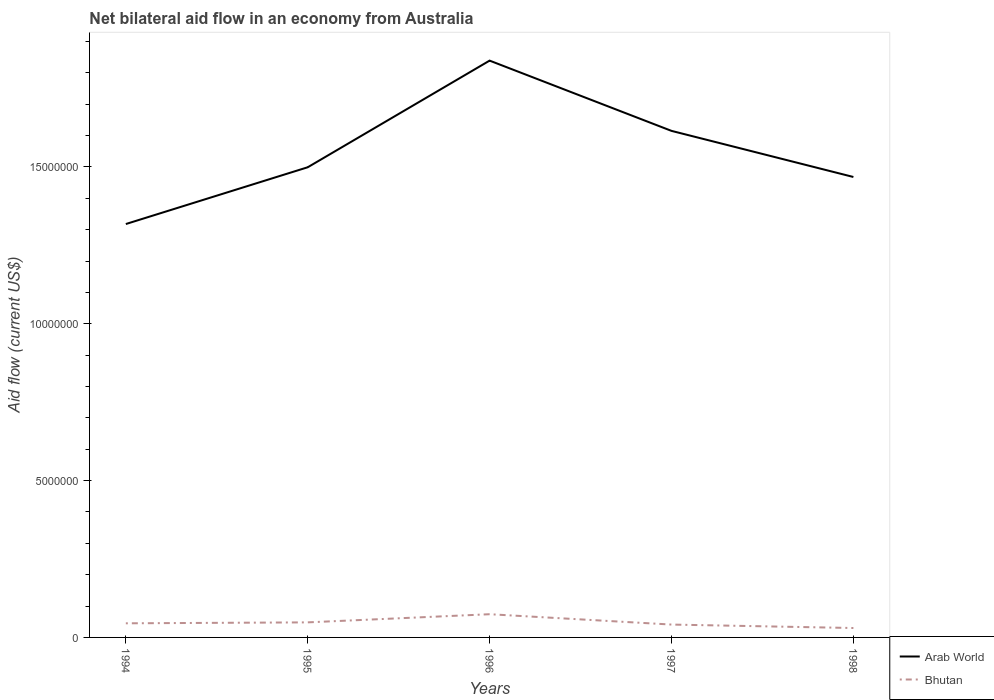Is the number of lines equal to the number of legend labels?
Your response must be concise. Yes. Across all years, what is the maximum net bilateral aid flow in Bhutan?
Make the answer very short. 3.00e+05. What is the total net bilateral aid flow in Arab World in the graph?
Make the answer very short. 2.24e+06. What is the difference between the highest and the second highest net bilateral aid flow in Bhutan?
Your response must be concise. 4.40e+05. Is the net bilateral aid flow in Bhutan strictly greater than the net bilateral aid flow in Arab World over the years?
Make the answer very short. Yes. Are the values on the major ticks of Y-axis written in scientific E-notation?
Your answer should be compact. No. Does the graph contain any zero values?
Your answer should be compact. No. How many legend labels are there?
Ensure brevity in your answer.  2. What is the title of the graph?
Your answer should be compact. Net bilateral aid flow in an economy from Australia. Does "Bulgaria" appear as one of the legend labels in the graph?
Your answer should be compact. No. What is the label or title of the X-axis?
Your answer should be very brief. Years. What is the label or title of the Y-axis?
Your answer should be compact. Aid flow (current US$). What is the Aid flow (current US$) of Arab World in 1994?
Your response must be concise. 1.32e+07. What is the Aid flow (current US$) in Arab World in 1995?
Ensure brevity in your answer.  1.50e+07. What is the Aid flow (current US$) in Arab World in 1996?
Give a very brief answer. 1.84e+07. What is the Aid flow (current US$) in Bhutan in 1996?
Offer a terse response. 7.40e+05. What is the Aid flow (current US$) in Arab World in 1997?
Keep it short and to the point. 1.62e+07. What is the Aid flow (current US$) of Arab World in 1998?
Offer a terse response. 1.47e+07. What is the Aid flow (current US$) of Bhutan in 1998?
Provide a succinct answer. 3.00e+05. Across all years, what is the maximum Aid flow (current US$) in Arab World?
Offer a very short reply. 1.84e+07. Across all years, what is the maximum Aid flow (current US$) of Bhutan?
Ensure brevity in your answer.  7.40e+05. Across all years, what is the minimum Aid flow (current US$) in Arab World?
Provide a short and direct response. 1.32e+07. What is the total Aid flow (current US$) in Arab World in the graph?
Provide a succinct answer. 7.74e+07. What is the total Aid flow (current US$) in Bhutan in the graph?
Keep it short and to the point. 2.38e+06. What is the difference between the Aid flow (current US$) of Arab World in 1994 and that in 1995?
Offer a very short reply. -1.81e+06. What is the difference between the Aid flow (current US$) of Arab World in 1994 and that in 1996?
Give a very brief answer. -5.21e+06. What is the difference between the Aid flow (current US$) of Bhutan in 1994 and that in 1996?
Provide a succinct answer. -2.90e+05. What is the difference between the Aid flow (current US$) in Arab World in 1994 and that in 1997?
Keep it short and to the point. -2.97e+06. What is the difference between the Aid flow (current US$) of Bhutan in 1994 and that in 1997?
Make the answer very short. 4.00e+04. What is the difference between the Aid flow (current US$) of Arab World in 1994 and that in 1998?
Make the answer very short. -1.50e+06. What is the difference between the Aid flow (current US$) in Arab World in 1995 and that in 1996?
Ensure brevity in your answer.  -3.40e+06. What is the difference between the Aid flow (current US$) of Bhutan in 1995 and that in 1996?
Offer a very short reply. -2.60e+05. What is the difference between the Aid flow (current US$) of Arab World in 1995 and that in 1997?
Give a very brief answer. -1.16e+06. What is the difference between the Aid flow (current US$) in Arab World in 1995 and that in 1998?
Provide a short and direct response. 3.10e+05. What is the difference between the Aid flow (current US$) of Bhutan in 1995 and that in 1998?
Your answer should be very brief. 1.80e+05. What is the difference between the Aid flow (current US$) of Arab World in 1996 and that in 1997?
Offer a terse response. 2.24e+06. What is the difference between the Aid flow (current US$) of Arab World in 1996 and that in 1998?
Your answer should be very brief. 3.71e+06. What is the difference between the Aid flow (current US$) of Bhutan in 1996 and that in 1998?
Ensure brevity in your answer.  4.40e+05. What is the difference between the Aid flow (current US$) of Arab World in 1997 and that in 1998?
Provide a short and direct response. 1.47e+06. What is the difference between the Aid flow (current US$) of Bhutan in 1997 and that in 1998?
Give a very brief answer. 1.10e+05. What is the difference between the Aid flow (current US$) in Arab World in 1994 and the Aid flow (current US$) in Bhutan in 1995?
Ensure brevity in your answer.  1.27e+07. What is the difference between the Aid flow (current US$) of Arab World in 1994 and the Aid flow (current US$) of Bhutan in 1996?
Make the answer very short. 1.24e+07. What is the difference between the Aid flow (current US$) in Arab World in 1994 and the Aid flow (current US$) in Bhutan in 1997?
Your answer should be very brief. 1.28e+07. What is the difference between the Aid flow (current US$) of Arab World in 1994 and the Aid flow (current US$) of Bhutan in 1998?
Provide a short and direct response. 1.29e+07. What is the difference between the Aid flow (current US$) in Arab World in 1995 and the Aid flow (current US$) in Bhutan in 1996?
Your answer should be compact. 1.42e+07. What is the difference between the Aid flow (current US$) of Arab World in 1995 and the Aid flow (current US$) of Bhutan in 1997?
Offer a terse response. 1.46e+07. What is the difference between the Aid flow (current US$) of Arab World in 1995 and the Aid flow (current US$) of Bhutan in 1998?
Your answer should be compact. 1.47e+07. What is the difference between the Aid flow (current US$) of Arab World in 1996 and the Aid flow (current US$) of Bhutan in 1997?
Offer a terse response. 1.80e+07. What is the difference between the Aid flow (current US$) in Arab World in 1996 and the Aid flow (current US$) in Bhutan in 1998?
Provide a short and direct response. 1.81e+07. What is the difference between the Aid flow (current US$) in Arab World in 1997 and the Aid flow (current US$) in Bhutan in 1998?
Your answer should be compact. 1.58e+07. What is the average Aid flow (current US$) of Arab World per year?
Your answer should be compact. 1.55e+07. What is the average Aid flow (current US$) of Bhutan per year?
Provide a short and direct response. 4.76e+05. In the year 1994, what is the difference between the Aid flow (current US$) of Arab World and Aid flow (current US$) of Bhutan?
Provide a short and direct response. 1.27e+07. In the year 1995, what is the difference between the Aid flow (current US$) of Arab World and Aid flow (current US$) of Bhutan?
Provide a succinct answer. 1.45e+07. In the year 1996, what is the difference between the Aid flow (current US$) in Arab World and Aid flow (current US$) in Bhutan?
Your answer should be very brief. 1.76e+07. In the year 1997, what is the difference between the Aid flow (current US$) in Arab World and Aid flow (current US$) in Bhutan?
Your response must be concise. 1.57e+07. In the year 1998, what is the difference between the Aid flow (current US$) of Arab World and Aid flow (current US$) of Bhutan?
Offer a terse response. 1.44e+07. What is the ratio of the Aid flow (current US$) of Arab World in 1994 to that in 1995?
Your answer should be very brief. 0.88. What is the ratio of the Aid flow (current US$) of Arab World in 1994 to that in 1996?
Provide a succinct answer. 0.72. What is the ratio of the Aid flow (current US$) in Bhutan in 1994 to that in 1996?
Provide a succinct answer. 0.61. What is the ratio of the Aid flow (current US$) of Arab World in 1994 to that in 1997?
Provide a succinct answer. 0.82. What is the ratio of the Aid flow (current US$) of Bhutan in 1994 to that in 1997?
Provide a short and direct response. 1.1. What is the ratio of the Aid flow (current US$) in Arab World in 1994 to that in 1998?
Provide a short and direct response. 0.9. What is the ratio of the Aid flow (current US$) of Arab World in 1995 to that in 1996?
Offer a very short reply. 0.82. What is the ratio of the Aid flow (current US$) of Bhutan in 1995 to that in 1996?
Provide a short and direct response. 0.65. What is the ratio of the Aid flow (current US$) of Arab World in 1995 to that in 1997?
Offer a very short reply. 0.93. What is the ratio of the Aid flow (current US$) of Bhutan in 1995 to that in 1997?
Keep it short and to the point. 1.17. What is the ratio of the Aid flow (current US$) in Arab World in 1995 to that in 1998?
Your answer should be very brief. 1.02. What is the ratio of the Aid flow (current US$) in Bhutan in 1995 to that in 1998?
Provide a succinct answer. 1.6. What is the ratio of the Aid flow (current US$) in Arab World in 1996 to that in 1997?
Your answer should be compact. 1.14. What is the ratio of the Aid flow (current US$) in Bhutan in 1996 to that in 1997?
Ensure brevity in your answer.  1.8. What is the ratio of the Aid flow (current US$) in Arab World in 1996 to that in 1998?
Keep it short and to the point. 1.25. What is the ratio of the Aid flow (current US$) in Bhutan in 1996 to that in 1998?
Your response must be concise. 2.47. What is the ratio of the Aid flow (current US$) in Arab World in 1997 to that in 1998?
Ensure brevity in your answer.  1.1. What is the ratio of the Aid flow (current US$) of Bhutan in 1997 to that in 1998?
Offer a terse response. 1.37. What is the difference between the highest and the second highest Aid flow (current US$) in Arab World?
Your response must be concise. 2.24e+06. What is the difference between the highest and the lowest Aid flow (current US$) in Arab World?
Provide a succinct answer. 5.21e+06. What is the difference between the highest and the lowest Aid flow (current US$) of Bhutan?
Offer a terse response. 4.40e+05. 